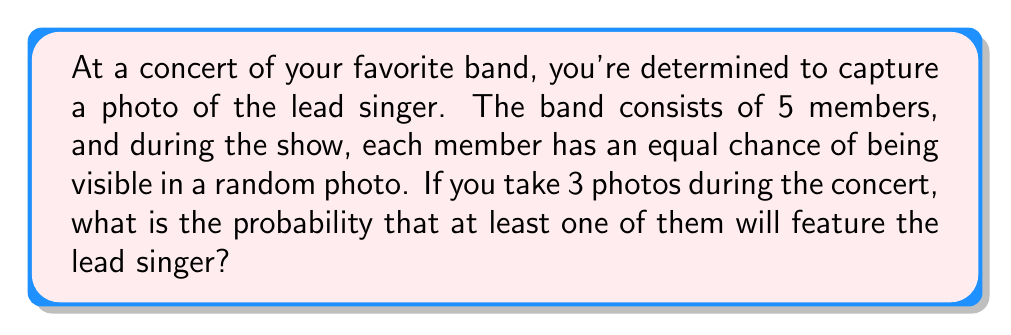Can you solve this math problem? Let's approach this step-by-step:

1) First, let's consider the probability of capturing the lead singer in a single photo:
   $P(\text{lead singer in one photo}) = \frac{1}{5}$

2) The probability of not capturing the lead singer in a single photo is:
   $P(\text{not lead singer}) = 1 - \frac{1}{5} = \frac{4}{5}$

3) For the lead singer to not appear in any of the 3 photos, we need to fail to capture them 3 times in a row. The probability of this is:
   $P(\text{no lead singer in 3 photos}) = (\frac{4}{5})^3 = \frac{64}{125}$

4) Therefore, the probability of capturing the lead singer in at least one of the 3 photos is the opposite of not capturing them at all:
   $P(\text{lead singer in at least one photo}) = 1 - P(\text{no lead singer in 3 photos})$
   $= 1 - \frac{64}{125} = \frac{125}{125} - \frac{64}{125} = \frac{61}{125}$

5) We can simplify this fraction:
   $\frac{61}{125} = 0.488 = 48.8\%$
Answer: $\frac{61}{125}$ or $48.8\%$ 